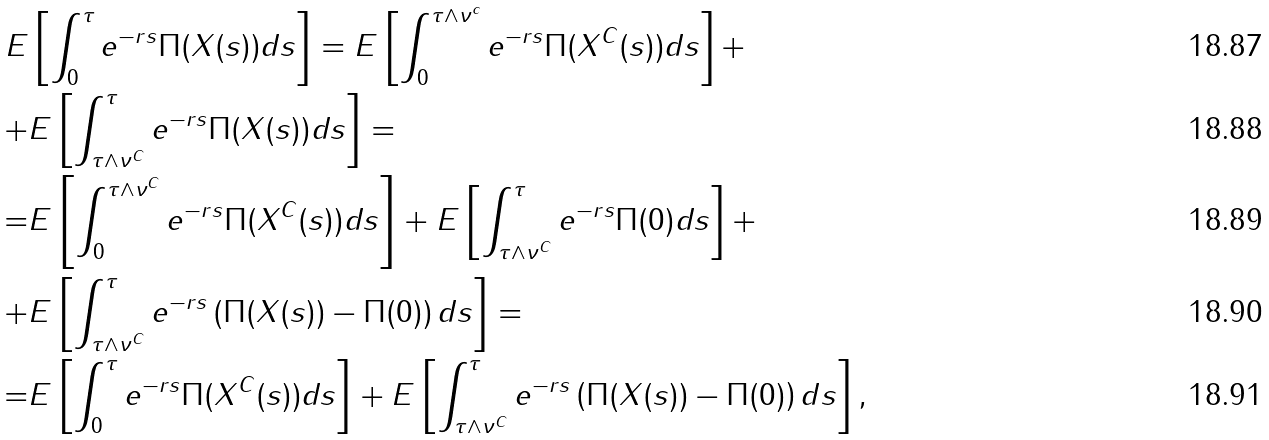Convert formula to latex. <formula><loc_0><loc_0><loc_500><loc_500>E & \left [ \int _ { 0 } ^ { \tau } e ^ { - r s } \Pi ( X ( s ) ) d s \right ] = E \left [ \int _ { 0 } ^ { \tau \wedge \nu ^ { c } } e ^ { - r s } \Pi ( X ^ { C } ( s ) ) d s \right ] + \\ + & E \left [ \int _ { \tau \wedge \nu ^ { C } } ^ { \tau } e ^ { - r s } \Pi ( X ( s ) ) d s \right ] = \\ = & E \left [ \int _ { 0 } ^ { \tau \wedge \nu ^ { C } } e ^ { - r s } \Pi ( X ^ { C } ( s ) ) d s \right ] + E \left [ \int _ { \tau \wedge \nu ^ { C } } ^ { \tau } e ^ { - r s } \Pi ( 0 ) d s \right ] + \\ + & E \left [ \int _ { \tau \wedge \nu ^ { C } } ^ { \tau } e ^ { - r s } \left ( \Pi ( X ( s ) ) - \Pi ( 0 ) \right ) d s \right ] = \\ = & E \left [ \int _ { 0 } ^ { \tau } e ^ { - r s } \Pi ( X ^ { C } ( s ) ) d s \right ] + E \left [ \int _ { \tau \wedge \nu ^ { C } } ^ { \tau } e ^ { - r s } \left ( \Pi ( X ( s ) ) - \Pi ( 0 ) \right ) d s \right ] ,</formula> 